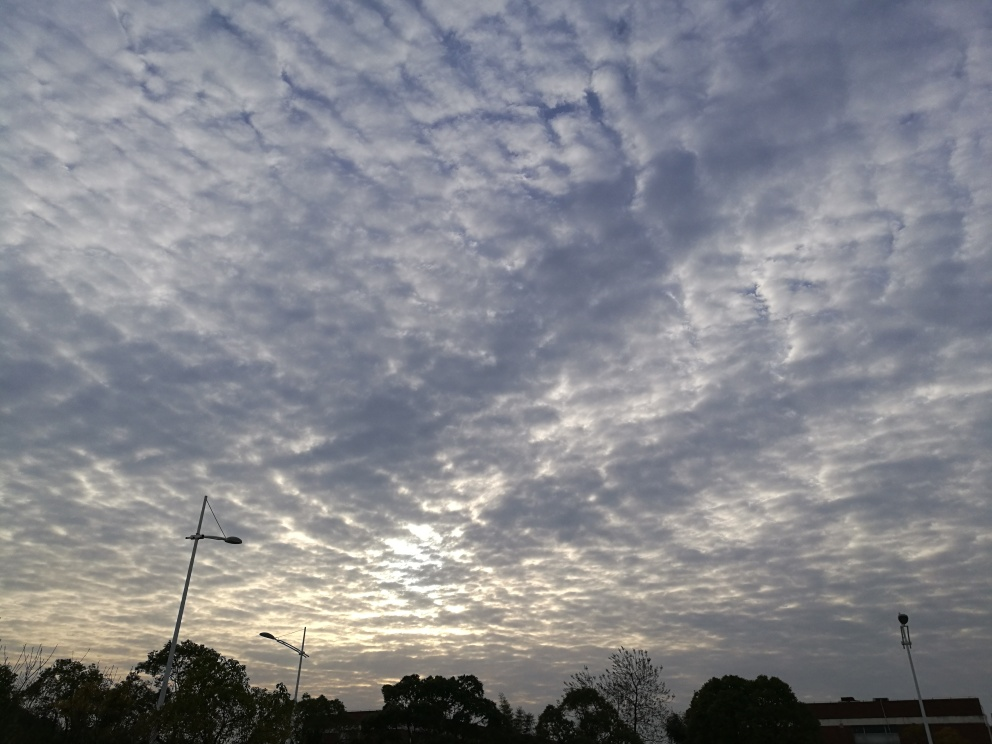What could be the geographical setting of this image? While the image does not provide definitive landmarks that could be used to determine the precise geographical location, the presence of street lamps and foliage indicates a developed urban or suburban area. The flat terrain suggests it could be in a plains region. 